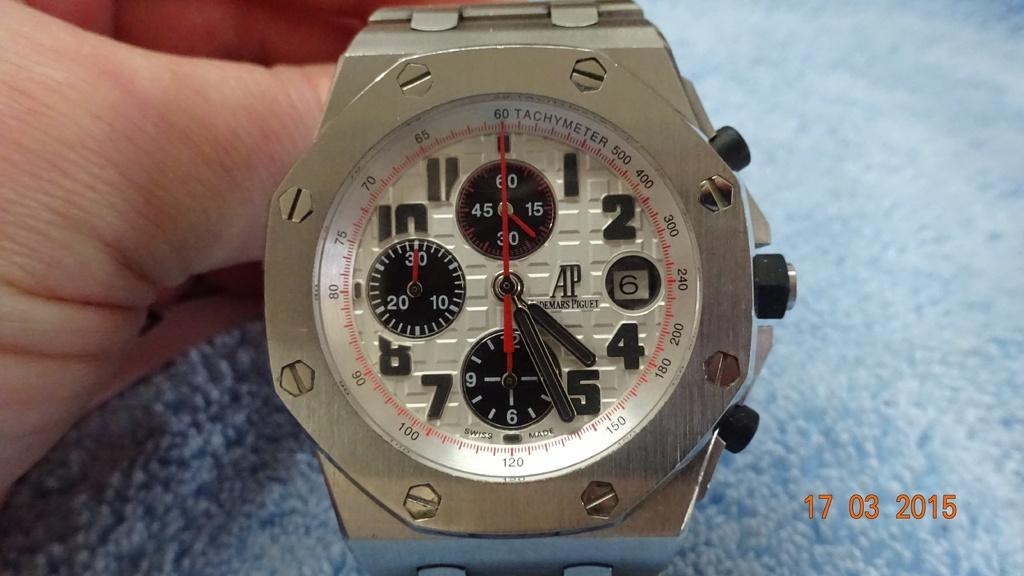Provide a one-sentence caption for the provided image. A heavy duty looking metal watch with a Tachymeter. 